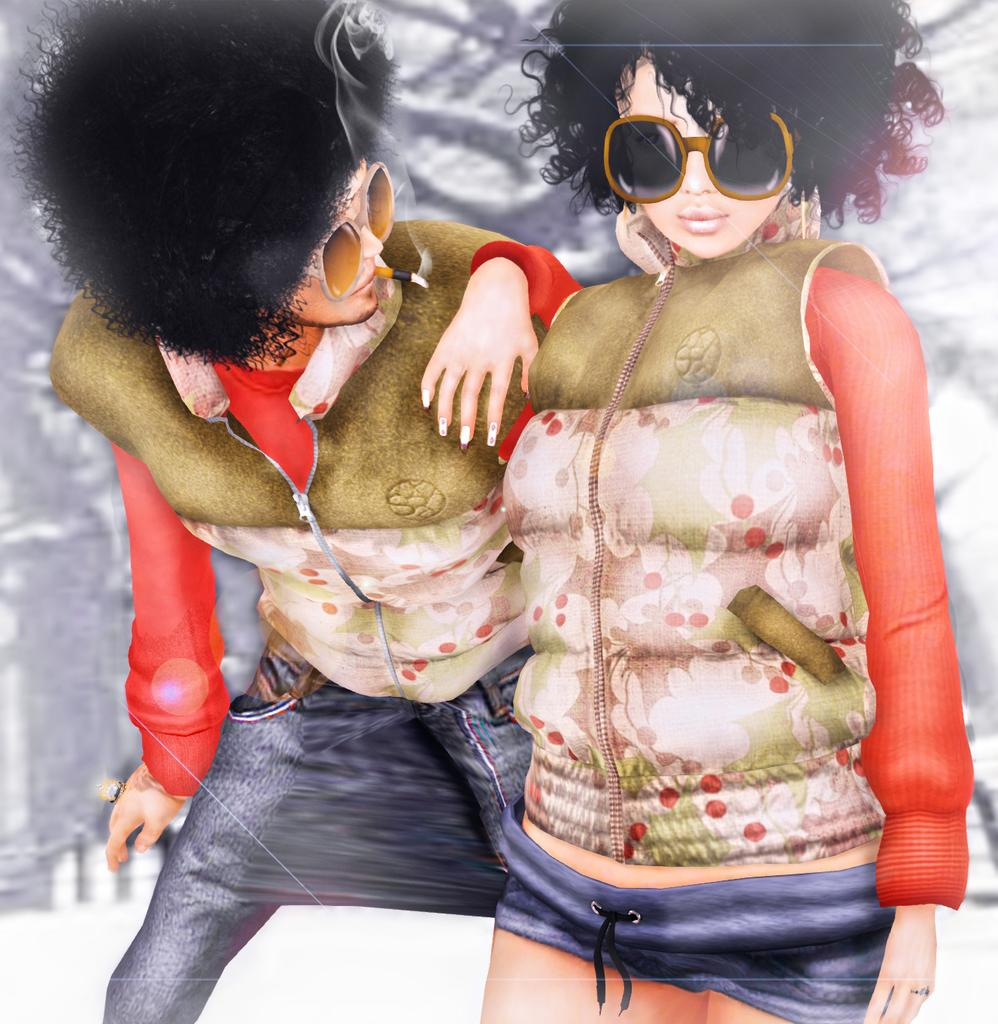Who are the people in the image? There is a man and a woman in the image. What are the man and woman wearing? They are both wearing jackets and goggles. What can be observed about the background of the image? The background of the image is blurred. What type of beetle can be seen crawling on the door in the image? There is no beetle or door present in the image. How many clovers are visible in the image? There are no clovers visible in the image. 